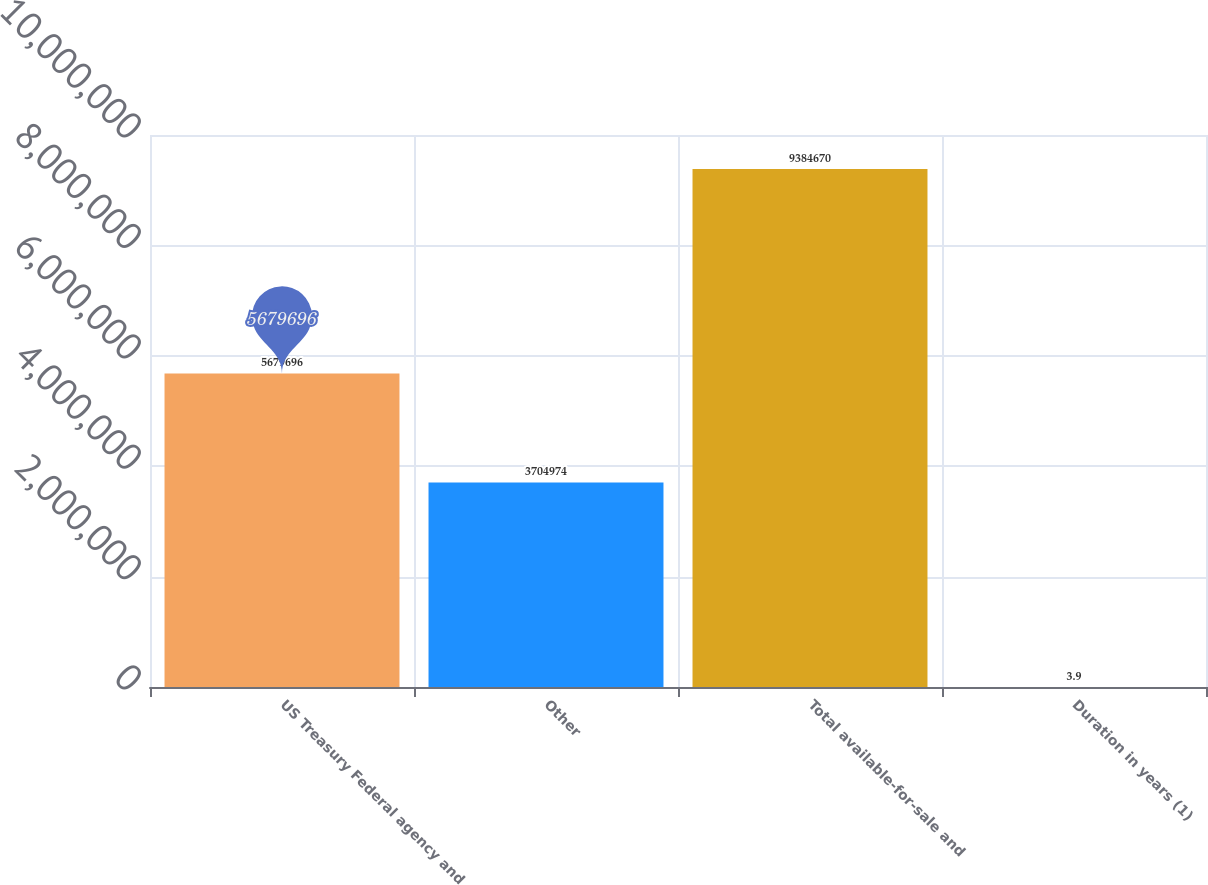Convert chart. <chart><loc_0><loc_0><loc_500><loc_500><bar_chart><fcel>US Treasury Federal agency and<fcel>Other<fcel>Total available-for-sale and<fcel>Duration in years (1)<nl><fcel>5.6797e+06<fcel>3.70497e+06<fcel>9.38467e+06<fcel>3.9<nl></chart> 